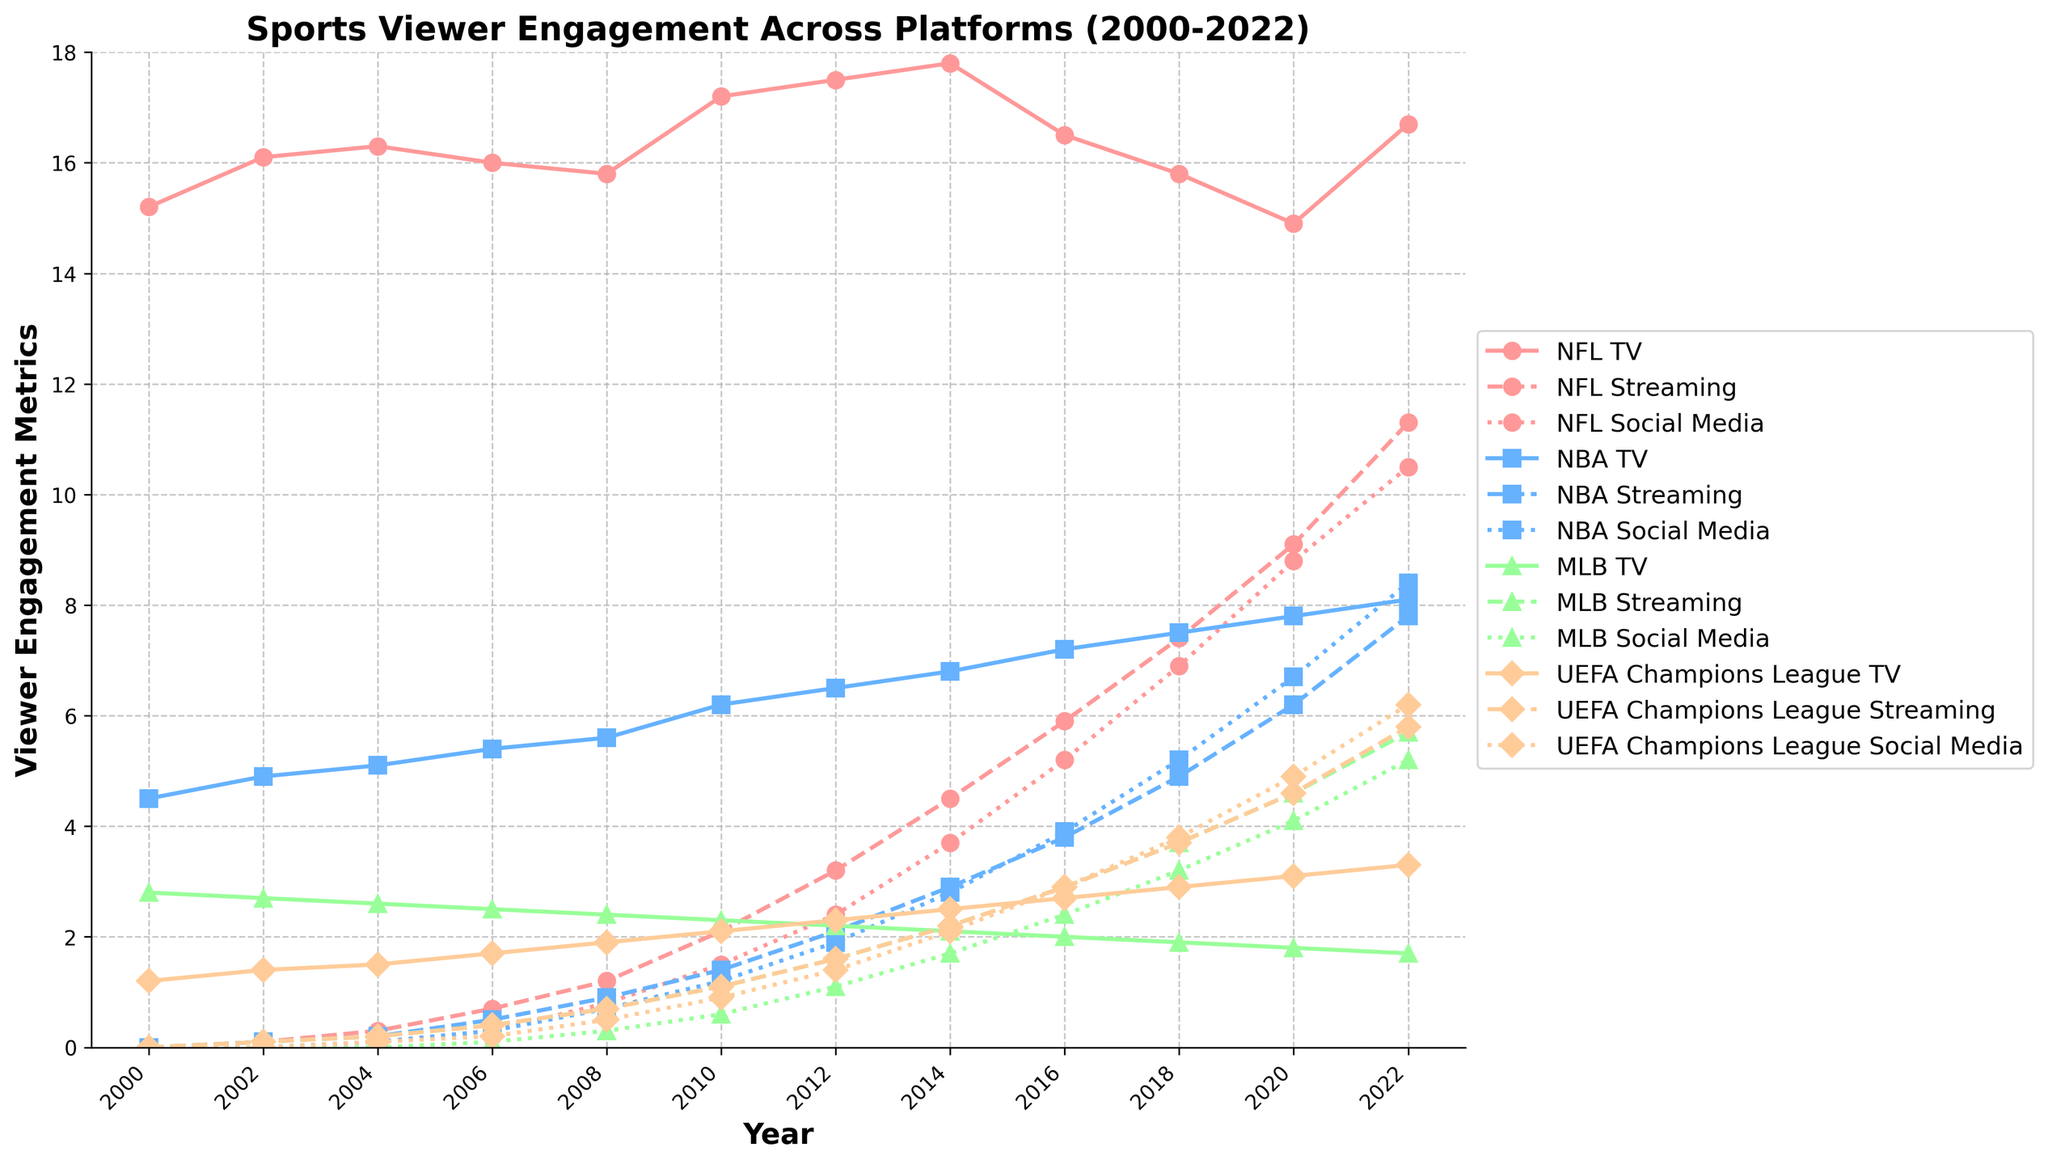What trends can you identify in viewer engagement for NFL on TV from 2000 to 2022? NFL TV viewer engagement starts at 15.2 in 2000, increases gradually to a peak of 17.8 in 2014, then declines to 14.9 by 2020, and finally rises again to 16.7 in 2022.
Answer: NFL TV viewer engagement generally increased, then decreased, and slightly increased again towards the end Which sport has the highest viewer engagement on social media in 2022? The social media viewer engagement data for 2022 shows NBA with 8.4, NFL with 10.5, MLB with 5.2, and UEFA Champions League with 6.2. Hence, NFL has the highest viewer engagement on social media.
Answer: NFL How does the streaming engagement for UEFA Champions League in 2010 compare to MLB streaming engagement in the same year? In 2010, UEFA Champions League streaming engagement is 1.1, and MLB streaming engagement is also 1.1. Therefore, they are equal.
Answer: Equal What is the average TV viewer engagement for NBA across the years provided? Add all the values of NBA TV viewer engagement and divide by the number of data points: (4.5 + 4.9 + 5.1 + 5.4 + 5.6 + 6.2 + 6.5 + 6.8 + 7.2 + 7.5 + 7.8 + 8.1) / 12 = 6.19.
Answer: 6.19 Which platform saw the greatest increase in viewer engagement metrics for UEFA Champions League from 2008 to 2022? Calculate the increase for each platform for UEFA Champions League: TV from 1.9 to 3.3 is +1.4, Streaming from 0.7 to 5.8 is +5.1, and Social Media from 0.5 to 6.2 is +5.7. Social Media has the greatest increase.
Answer: Social Media Between 2014 and 2018, which sport had the largest decline in TV viewer engagement? Compare TV viewer engagement from 2014 to 2018: NFL from 17.8 to 15.8 (decrease of 2.0), NBA from 6.8 to 7.5 (increase of 0.7), MLB from 2.1 to 1.9 (decrease of 0.2), and UEFA Champions League from 2.5 to 2.9 (increase of 0.4). NFL had the largest decline.
Answer: NFL For the year 2022, rank the sports based on their streaming viewer engagement from highest to lowest. Streaming viewer engagement in 2022 for NFL is 11.3, NBA is 7.8, MLB is 5.7, and UEFA Champions League is 5.8. Ranking from highest to lowest: NFL, NBA, UEFA Champions League, MLB.
Answer: NFL, NBA, UEFA Champions League, MLB How much did MLB social media engagement increase from 2006 to 2022? MLB social media engagement in 2006 is 0.1, and in 2022, it is 5.2. The increase is 5.2 - 0.1 = 5.1.
Answer: 5.1 Compare the total viewer engagement across all platforms for NBA in 2012. Sum the viewer engagement across all platforms for NBA in 2012: TV (6.5) + Streaming (2.1) + Social Media (1.9) = 10.5.
Answer: 10.5 